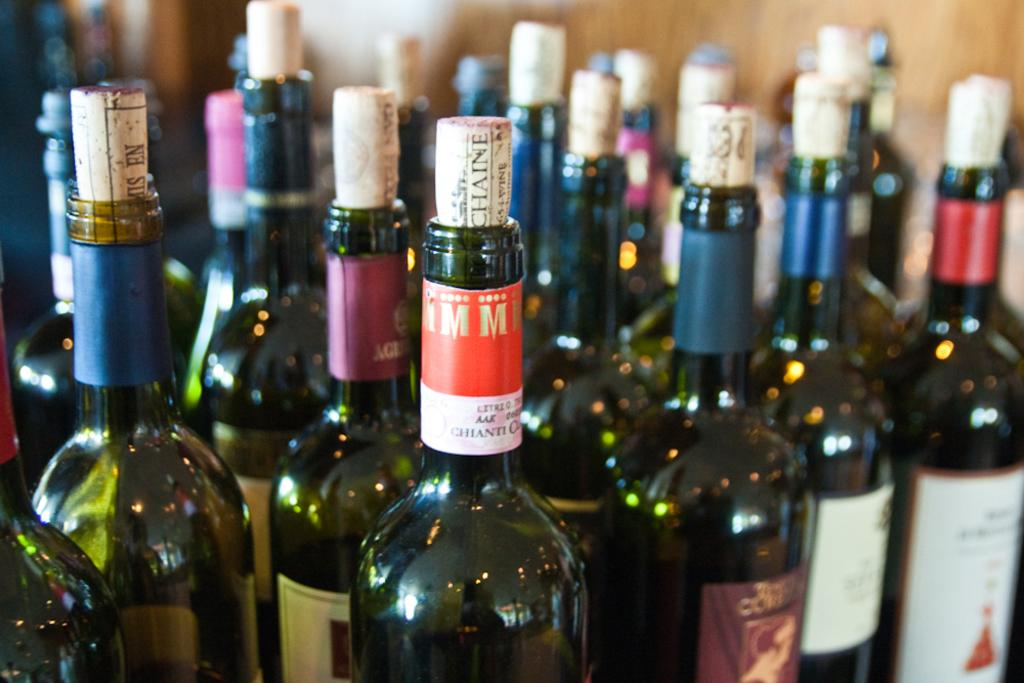<image>
Share a concise interpretation of the image provided. many bottles of previously opened wine are sitting together, including a chianti 